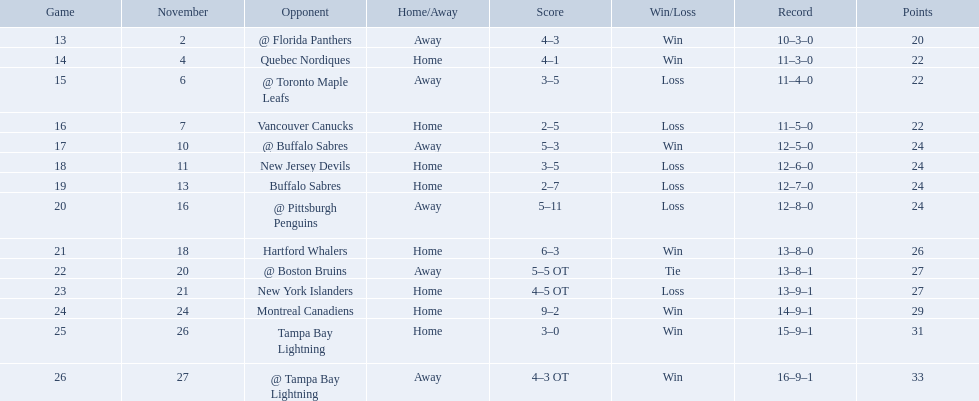Who did the philadelphia flyers play in game 17? @ Buffalo Sabres. What was the score of the november 10th game against the buffalo sabres? 5–3. Which team in the atlantic division had less points than the philadelphia flyers? Tampa Bay Lightning. What were the scores? @ Florida Panthers, 4–3, Quebec Nordiques, 4–1, @ Toronto Maple Leafs, 3–5, Vancouver Canucks, 2–5, @ Buffalo Sabres, 5–3, New Jersey Devils, 3–5, Buffalo Sabres, 2–7, @ Pittsburgh Penguins, 5–11, Hartford Whalers, 6–3, @ Boston Bruins, 5–5 OT, New York Islanders, 4–5 OT, Montreal Canadiens, 9–2, Tampa Bay Lightning, 3–0, @ Tampa Bay Lightning, 4–3 OT. What score was the closest? New York Islanders, 4–5 OT. What team had that score? New York Islanders. 